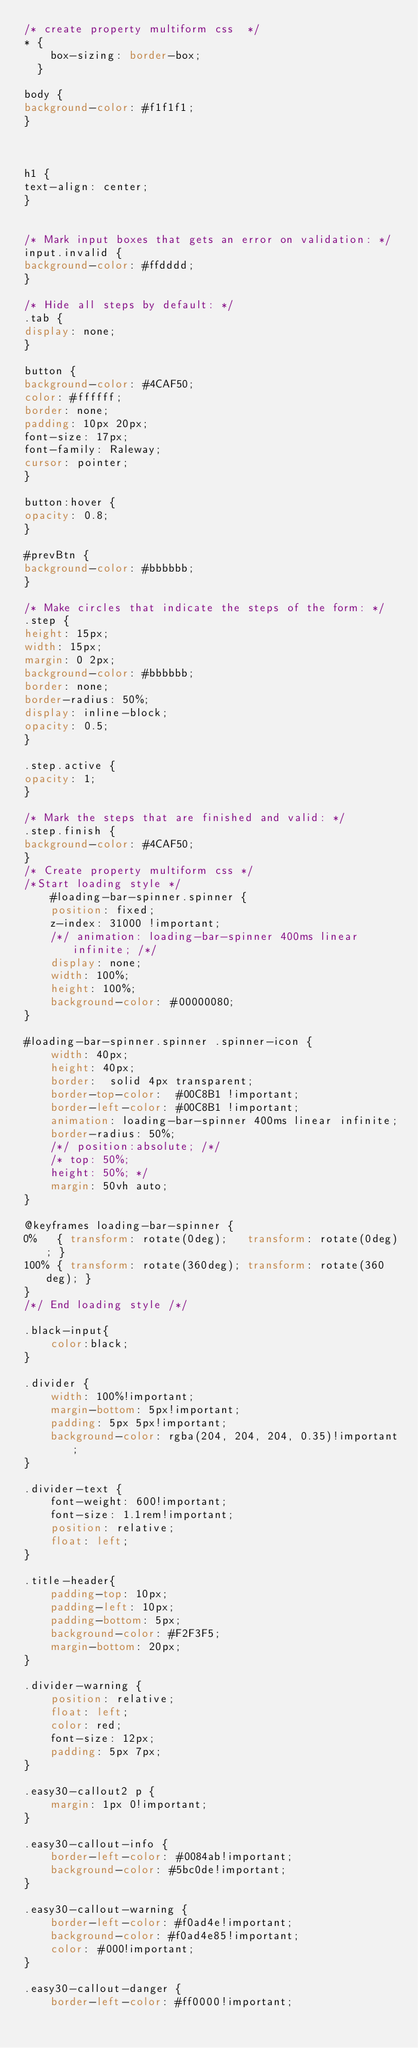<code> <loc_0><loc_0><loc_500><loc_500><_CSS_>/* create property multiform css  */
* {
    box-sizing: border-box;
  }

body {
background-color: #f1f1f1;
}



h1 {
text-align: center;  
}


/* Mark input boxes that gets an error on validation: */
input.invalid {
background-color: #ffdddd;
}

/* Hide all steps by default: */
.tab {
display: none;
}

button {
background-color: #4CAF50;
color: #ffffff;
border: none;
padding: 10px 20px;
font-size: 17px;
font-family: Raleway;
cursor: pointer;
}

button:hover {
opacity: 0.8;
}

#prevBtn {
background-color: #bbbbbb;
}

/* Make circles that indicate the steps of the form: */
.step {
height: 15px;
width: 15px;
margin: 0 2px;
background-color: #bbbbbb;
border: none;  
border-radius: 50%;
display: inline-block;
opacity: 0.5;
}

.step.active {
opacity: 1;
}

/* Mark the steps that are finished and valid: */
.step.finish {
background-color: #4CAF50;
}
/* Create property multiform css */
/*Start loading style */
    #loading-bar-spinner.spinner {
    position: fixed;
    z-index: 31000 !important;
    /*/ animation: loading-bar-spinner 400ms linear infinite; /*/
    display: none;
    width: 100%;
    height: 100%;
    background-color: #00000080;
}

#loading-bar-spinner.spinner .spinner-icon {
    width: 40px;
    height: 40px;
    border:  solid 4px transparent;
    border-top-color:  #00C8B1 !important;
    border-left-color: #00C8B1 !important;
    animation: loading-bar-spinner 400ms linear infinite;
    border-radius: 50%;
    /*/ position:absolute; /*/
    /* top: 50%;
    height: 50%; */
    margin: 50vh auto;
}

@keyframes loading-bar-spinner {
0%   { transform: rotate(0deg);   transform: rotate(0deg); }
100% { transform: rotate(360deg); transform: rotate(360deg); }
}
/*/ End loading style /*/

.black-input{
    color:black;
}

.divider {
    width: 100%!important;
    margin-bottom: 5px!important;
    padding: 5px 5px!important;
    background-color: rgba(204, 204, 204, 0.35)!important;
}

.divider-text {
    font-weight: 600!important;
    font-size: 1.1rem!important;
    position: relative;
    float: left;
}

.title-header{
	padding-top: 10px;
	padding-left: 10px;
	padding-bottom: 5px; 
	background-color: #F2F3F5;
	margin-bottom: 20px;
}

.divider-warning {
    position: relative;
    float: left;
    color: red;
    font-size: 12px;
    padding: 5px 7px;
}

.easy30-callout2 p {
    margin: 1px 0!important;
}

.easy30-callout-info {
    border-left-color: #0084ab!important;
    background-color: #5bc0de!important;
}

.easy30-callout-warning {
    border-left-color: #f0ad4e!important;
    background-color: #f0ad4e85!important;
    color: #000!important;
}

.easy30-callout-danger {
    border-left-color: #ff0000!important;</code> 